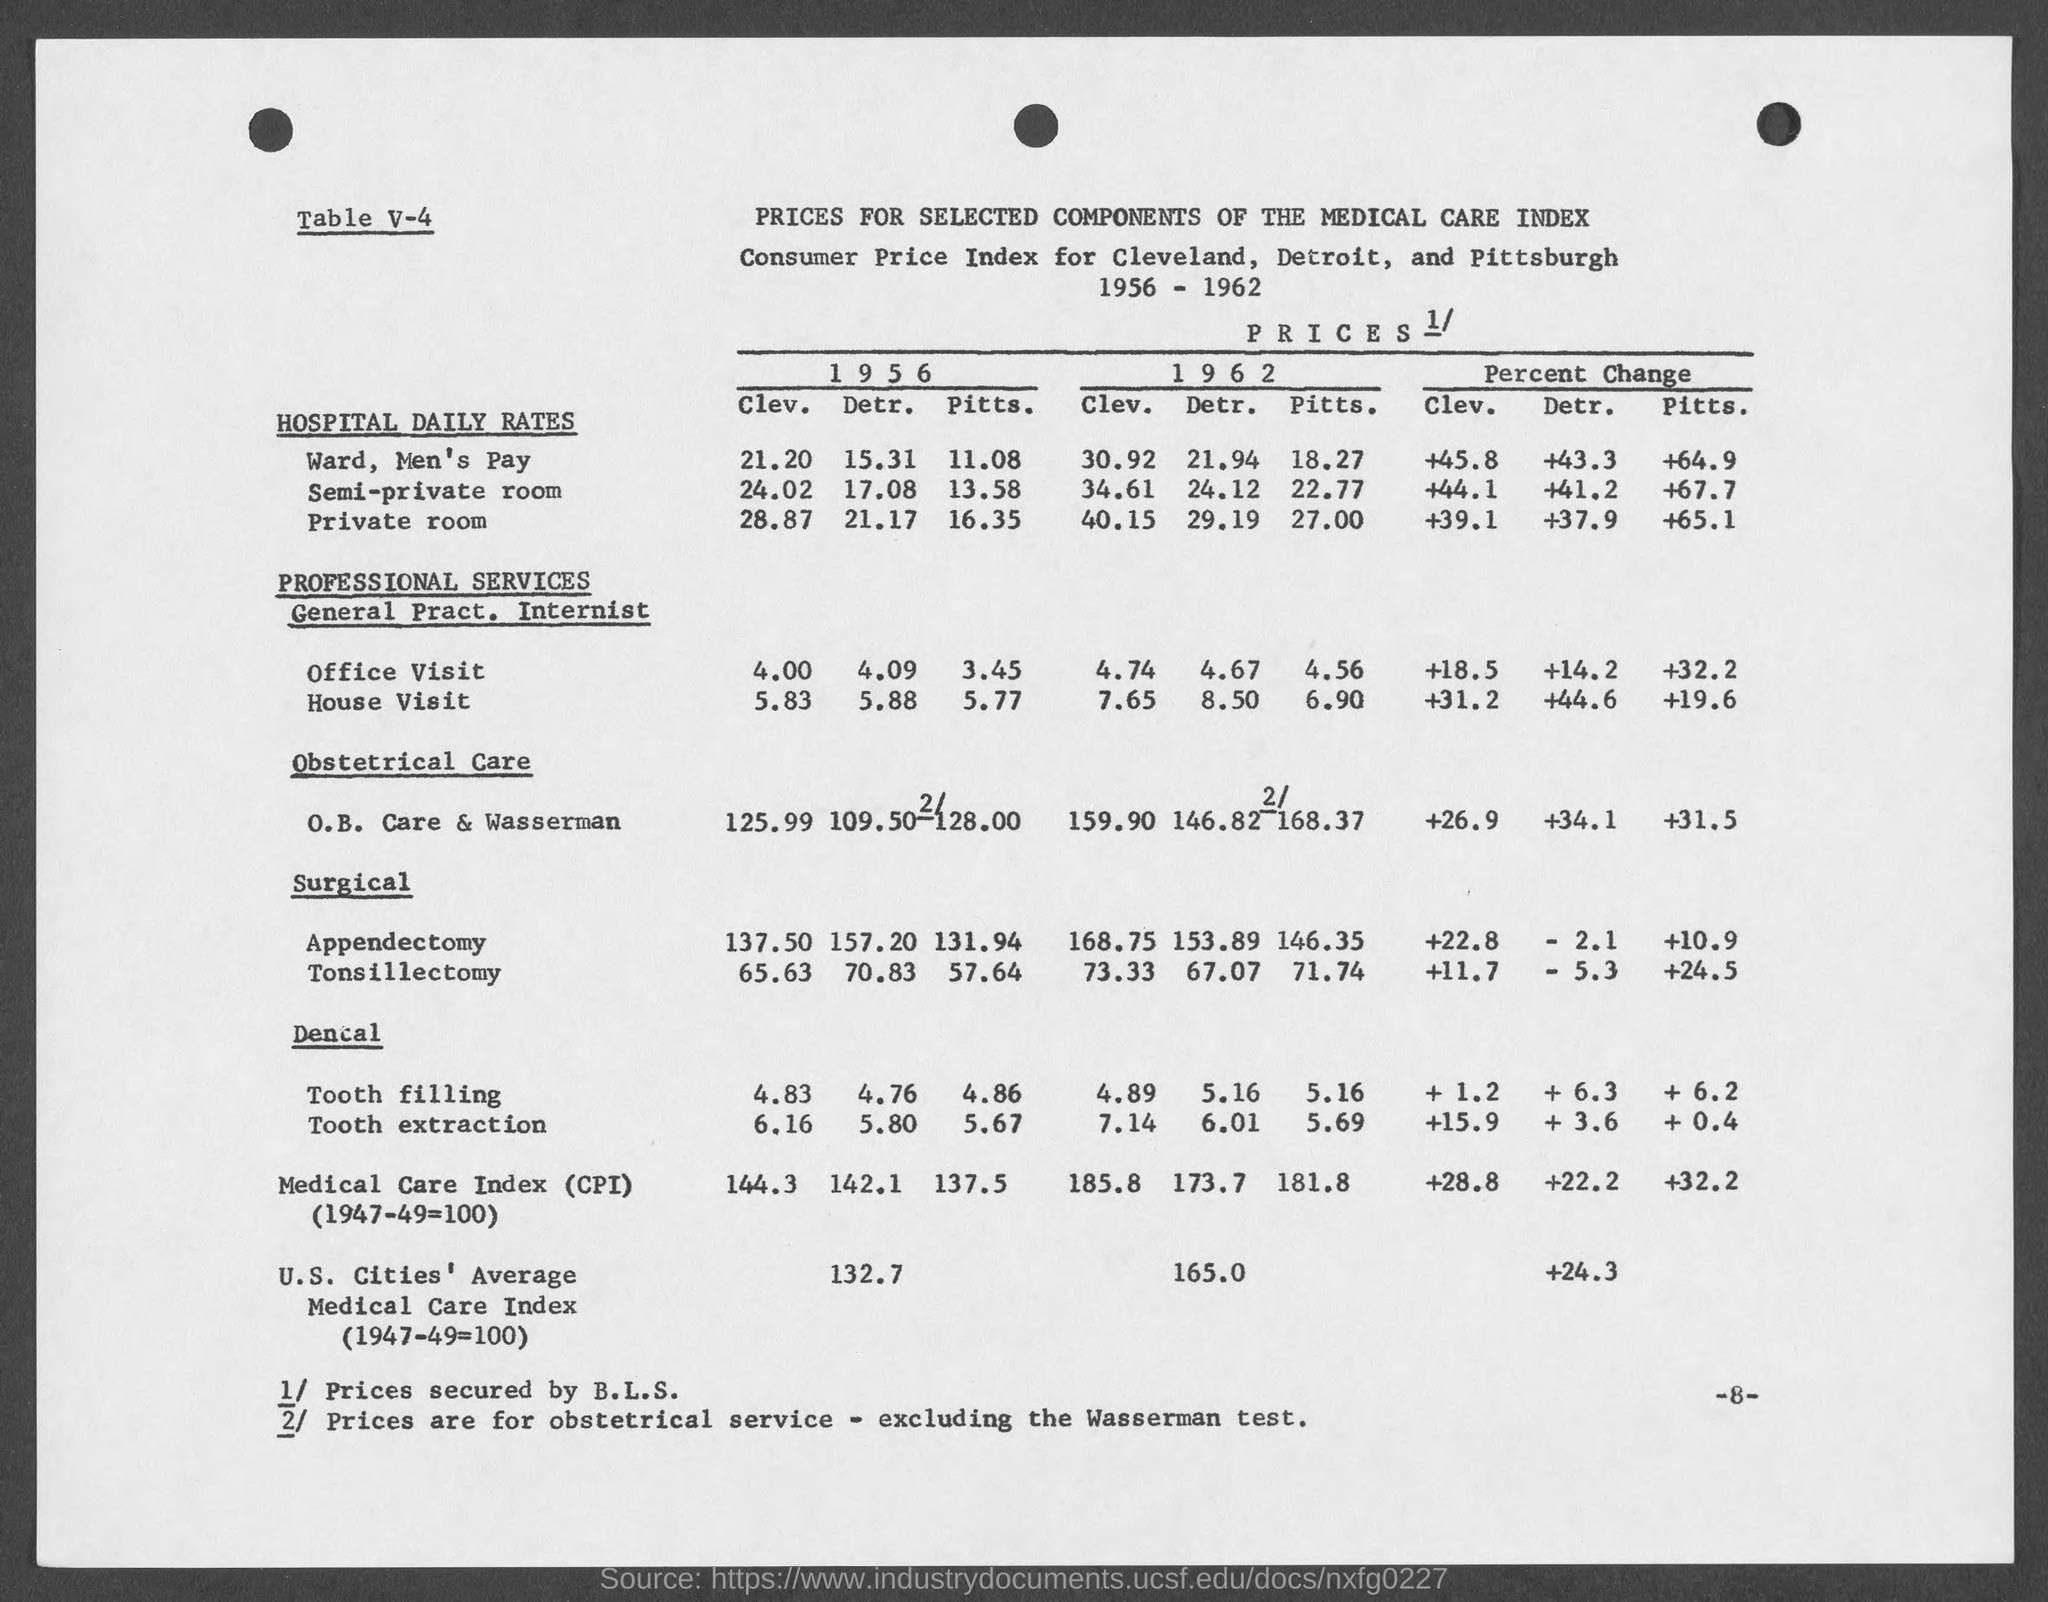What is the number at bottom right of the page?
Offer a very short reply. 8. 